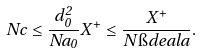Convert formula to latex. <formula><loc_0><loc_0><loc_500><loc_500>N c \leq \frac { d _ { 0 } ^ { 2 } } { N a _ { 0 } } X ^ { + } \leq \frac { X ^ { + } } { N \i d e a l { a } } .</formula> 